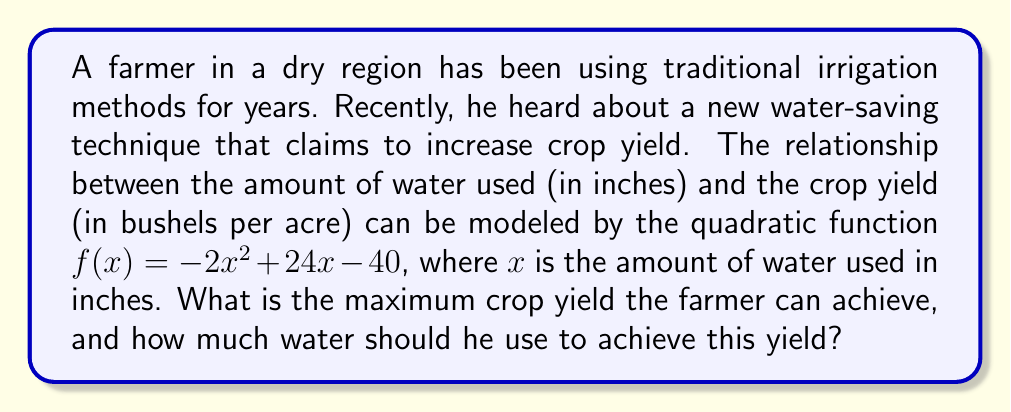Can you solve this math problem? To find the maximum crop yield and the corresponding amount of water, we need to follow these steps:

1) The given quadratic function is in the form $f(x) = -2x^2 + 24x - 40$

2) For a quadratic function in the form $f(x) = ax^2 + bx + c$, the x-coordinate of the vertex (which gives the maximum or minimum point) is given by $x = -\frac{b}{2a}$

3) In this case, $a = -2$ and $b = 24$. Let's substitute these values:

   $x = -\frac{24}{2(-2)} = -\frac{24}{-4} = 6$

4) This means the maximum yield occurs when 6 inches of water is used.

5) To find the maximum yield, we need to calculate $f(6)$:

   $f(6) = -2(6)^2 + 24(6) - 40$
   $= -2(36) + 144 - 40$
   $= -72 + 144 - 40$
   $= 32$

Therefore, the maximum crop yield is 32 bushels per acre, achieved when using 6 inches of water.
Answer: Maximum yield: 32 bushels/acre; Water needed: 6 inches 